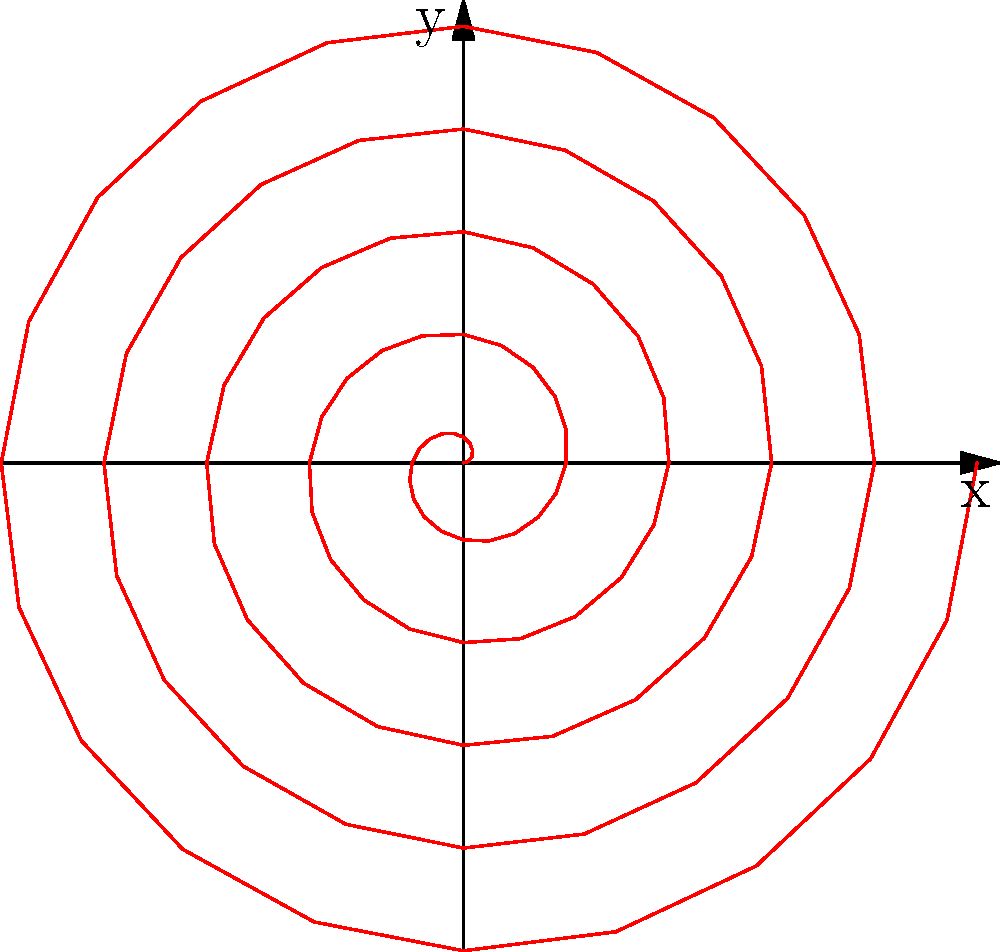As a newly hired software engineer working on a data visualization project, you need to plot a spiral function in polar coordinates. Given the function $r = 0.1\theta$, where $r$ is the radius and $\theta$ is the angle in radians, what is the maximum number of complete revolutions shown in the spiral plot if $\theta$ ranges from $0$ to $10\pi$? To determine the number of complete revolutions in the spiral plot, we need to follow these steps:

1. Understand that one complete revolution corresponds to $2\pi$ radians.

2. Given that $\theta$ ranges from $0$ to $10\pi$, we can calculate the number of revolutions:

   $$\text{Number of revolutions} = \frac{\text{Total angle}}{\text{Angle for one revolution}} = \frac{10\pi}{2\pi} = 5$$

3. Since we're asked for the maximum number of complete revolutions, we need to consider only the whole number part of this result.

4. The spiral makes exactly 5 complete revolutions.

5. Verify this visually by counting the number of times the spiral crosses the positive x-axis in the plot.
Answer: 5 revolutions 